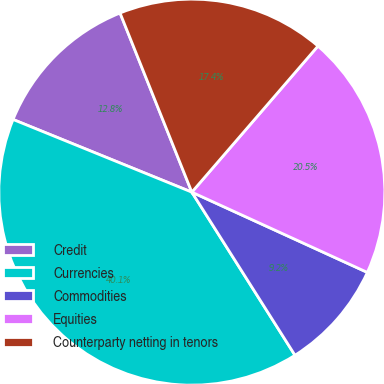<chart> <loc_0><loc_0><loc_500><loc_500><pie_chart><fcel>Credit<fcel>Currencies<fcel>Commodities<fcel>Equities<fcel>Counterparty netting in tenors<nl><fcel>12.79%<fcel>40.12%<fcel>9.2%<fcel>20.49%<fcel>17.4%<nl></chart> 